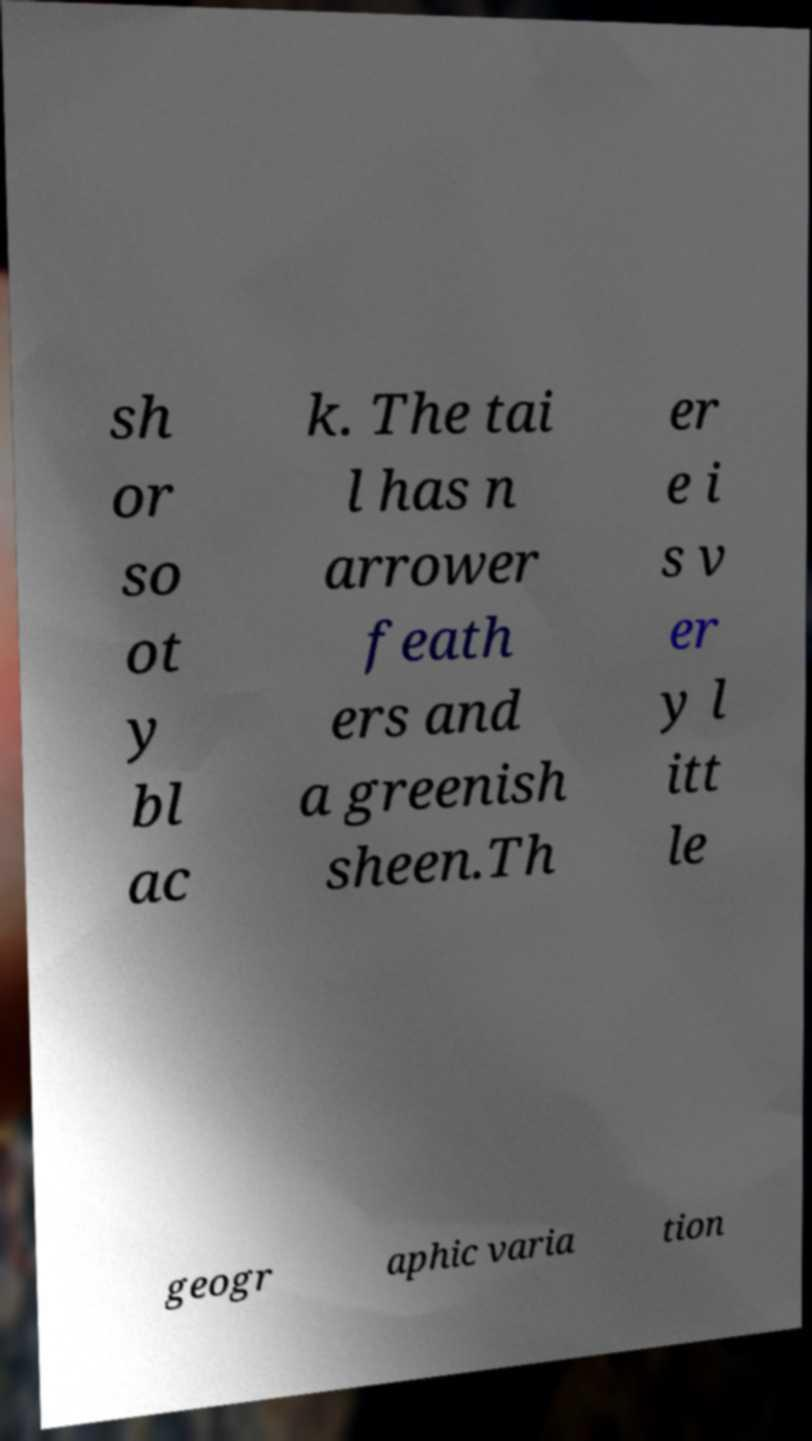I need the written content from this picture converted into text. Can you do that? sh or so ot y bl ac k. The tai l has n arrower feath ers and a greenish sheen.Th er e i s v er y l itt le geogr aphic varia tion 